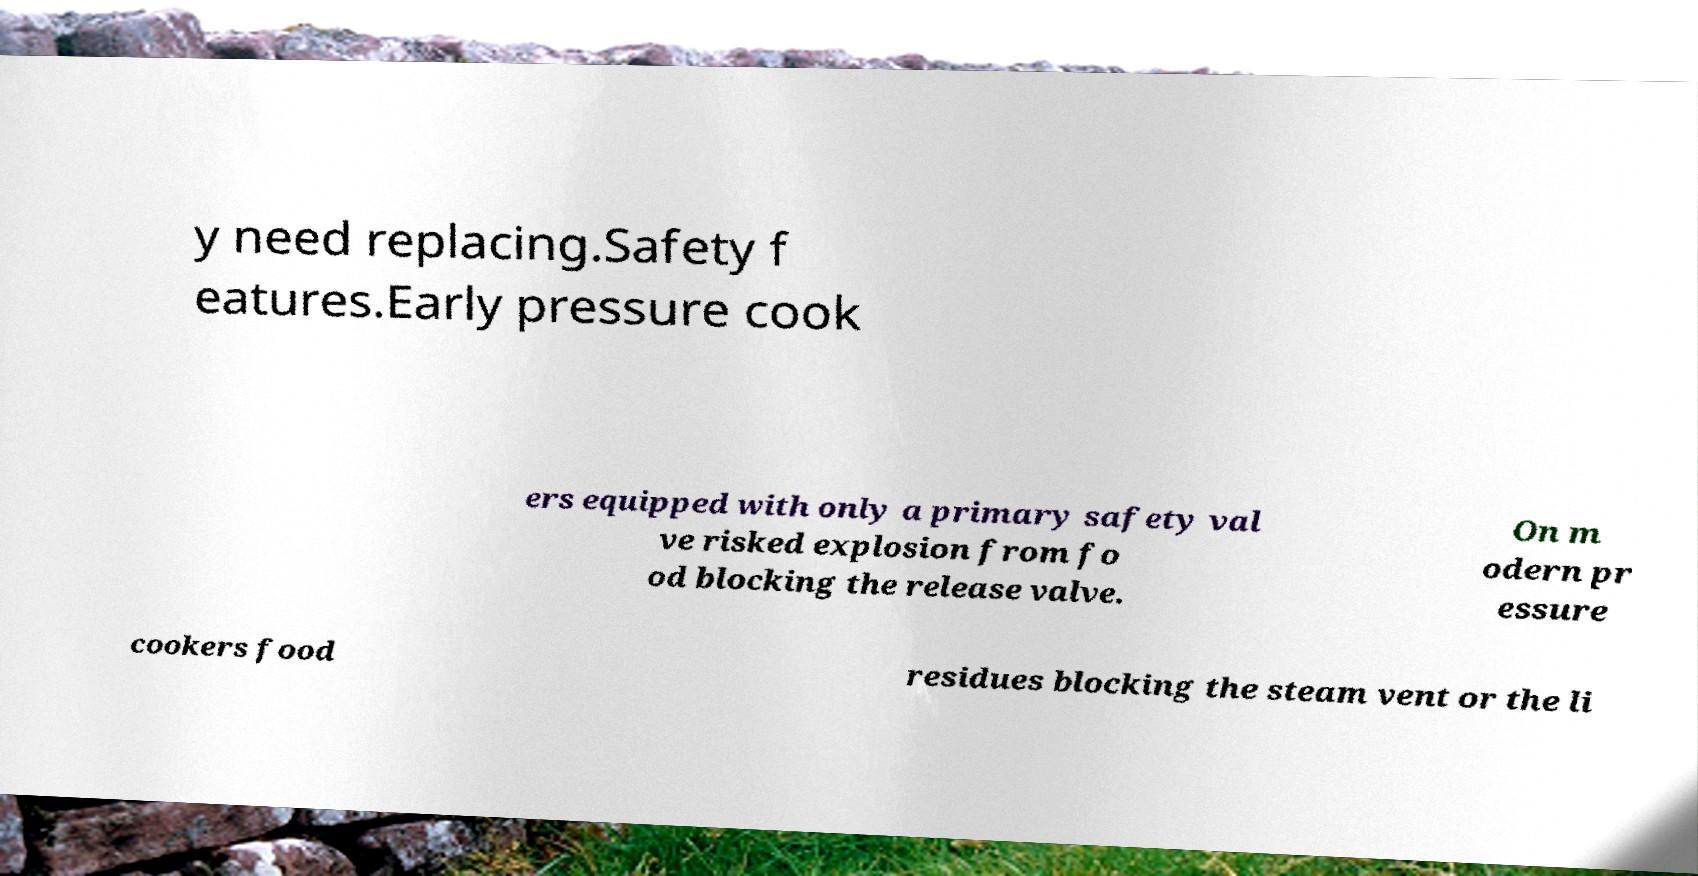Please identify and transcribe the text found in this image. y need replacing.Safety f eatures.Early pressure cook ers equipped with only a primary safety val ve risked explosion from fo od blocking the release valve. On m odern pr essure cookers food residues blocking the steam vent or the li 